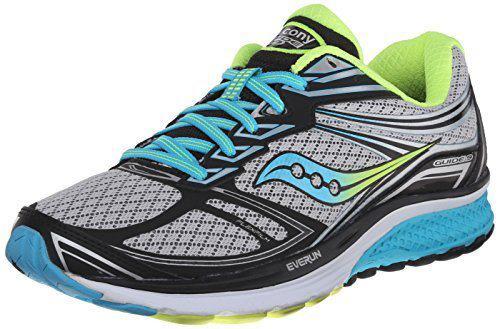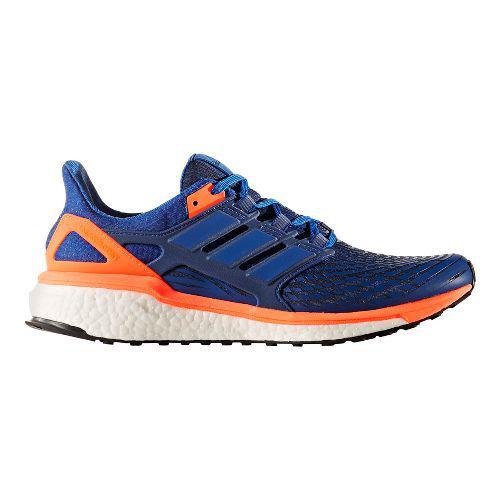The first image is the image on the left, the second image is the image on the right. Evaluate the accuracy of this statement regarding the images: "In one image, a shoe featuring turquise, gray, and lime green is laced with turquoise colored strings, and is positioned so the toe section is angled towards the front.". Is it true? Answer yes or no. Yes. The first image is the image on the left, the second image is the image on the right. Given the left and right images, does the statement "Each image contains a single sneaker, and the sneakers in the right and left images face the same direction." hold true? Answer yes or no. No. 